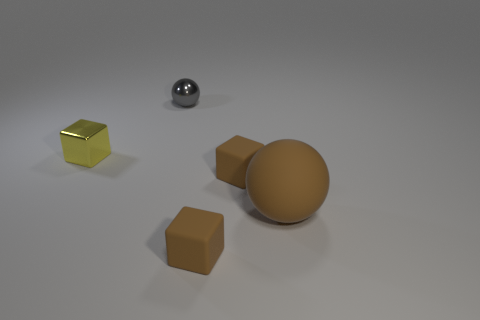Does the gray shiny thing have the same size as the shiny block?
Your response must be concise. Yes. Are there the same number of brown cubes that are in front of the big brown object and tiny gray shiny things that are to the right of the small gray metal object?
Give a very brief answer. No. Is there a blue rubber sphere?
Ensure brevity in your answer.  No. There is another object that is the same shape as the gray metal thing; what is its size?
Provide a short and direct response. Large. How big is the metal thing that is left of the gray thing?
Offer a terse response. Small. Is the number of gray shiny things that are on the left side of the tiny yellow object greater than the number of blue metal balls?
Ensure brevity in your answer.  No. The yellow metal object is what shape?
Provide a short and direct response. Cube. There is a rubber object in front of the brown ball; does it have the same color as the big sphere right of the small sphere?
Provide a succinct answer. Yes. Does the tiny yellow thing have the same shape as the big matte object?
Your answer should be compact. No. Are there any other things that are the same shape as the tiny yellow metallic thing?
Make the answer very short. Yes. 